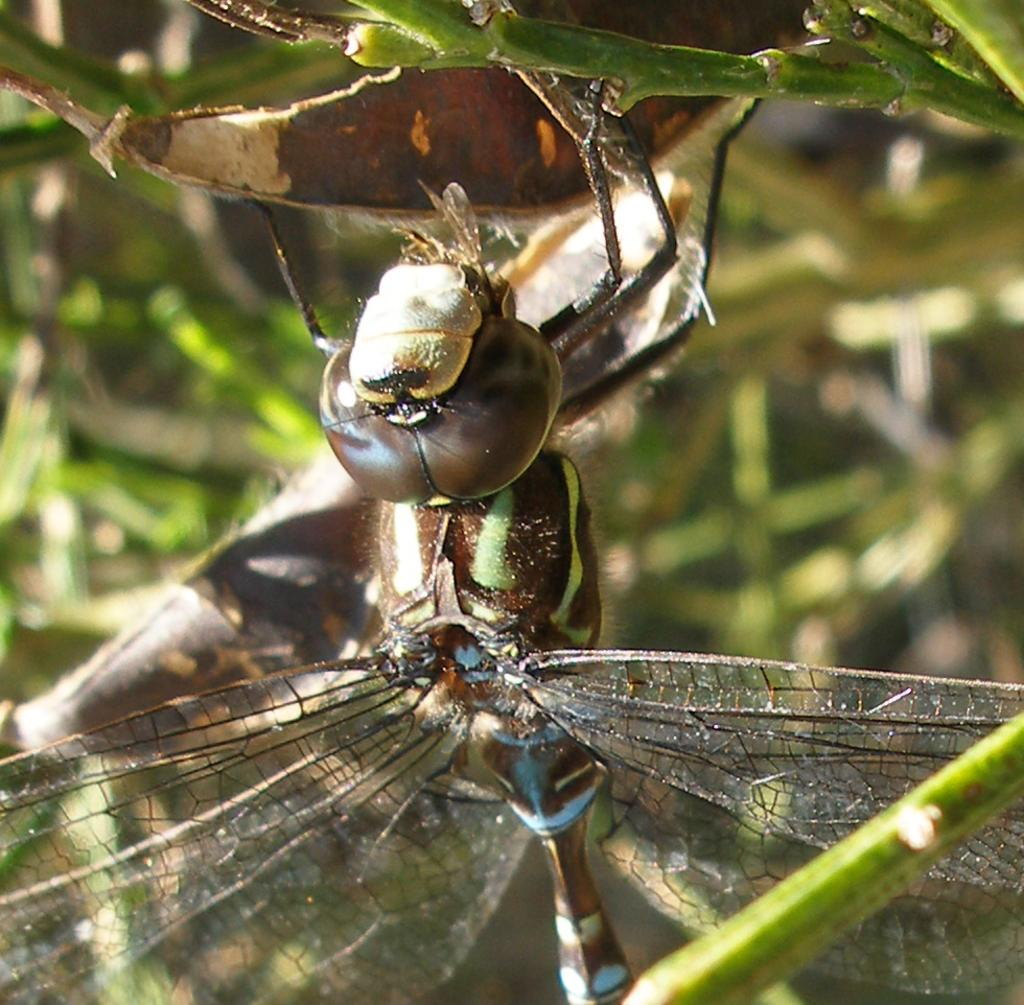Where was the image taken? The image was taken outdoors. What can be seen in the background of the image? There is a plant in the background of the image. What is the main subject of the image? The main subject of the image is a dragonfly on a leaf. How much money is the dragonfly holding in the image? The dragonfly is not holding any money in the image; it is a dragonfly on a leaf. 